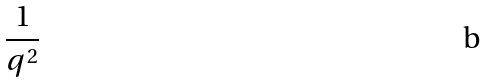Convert formula to latex. <formula><loc_0><loc_0><loc_500><loc_500>\frac { 1 } { q ^ { 2 } }</formula> 